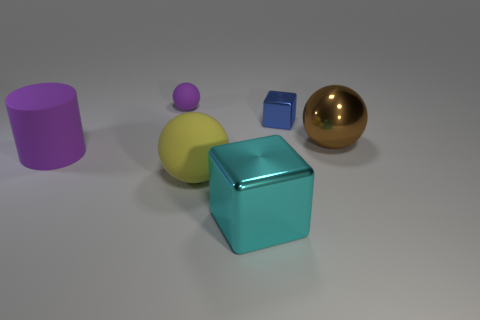Add 2 tiny rubber things. How many objects exist? 8 Subtract all blocks. How many objects are left? 4 Add 6 yellow matte balls. How many yellow matte balls are left? 7 Add 1 big brown shiny balls. How many big brown shiny balls exist? 2 Subtract 1 cyan blocks. How many objects are left? 5 Subtract all brown balls. Subtract all brown metal balls. How many objects are left? 4 